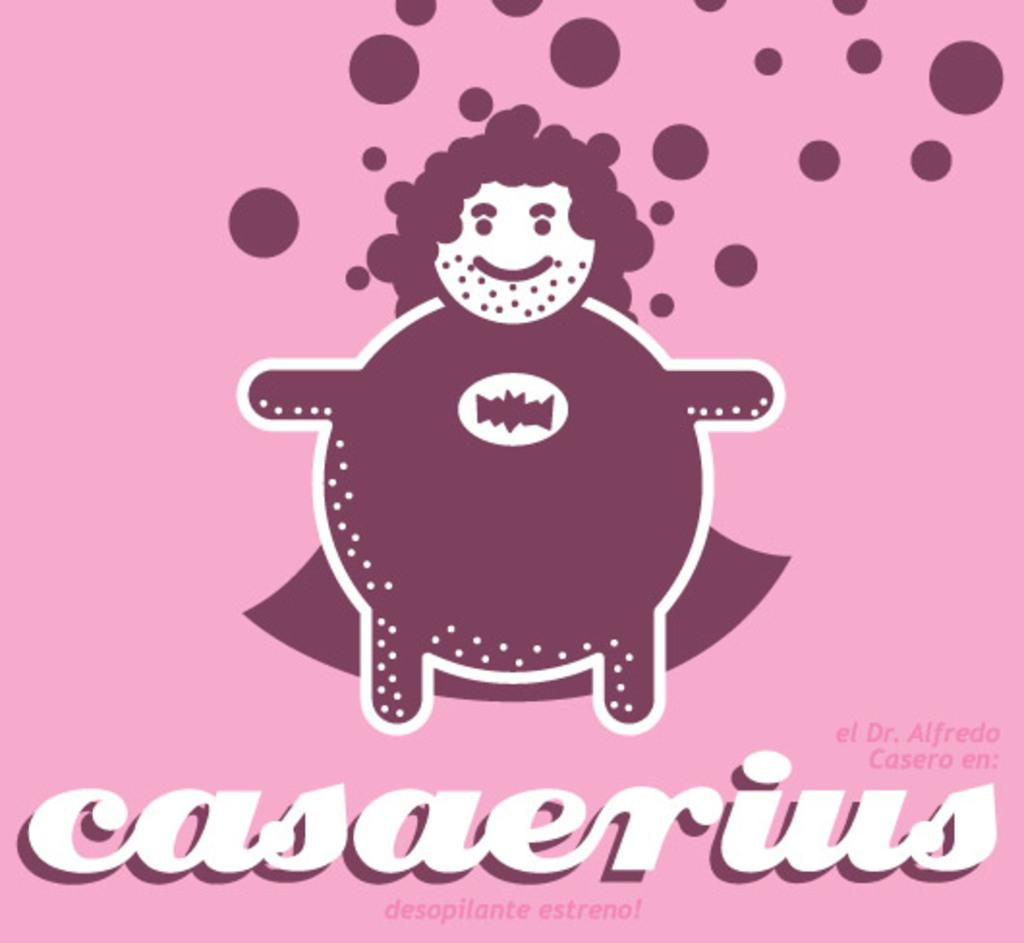<image>
Describe the image concisely. A pink and purple banner for the album casaerius 